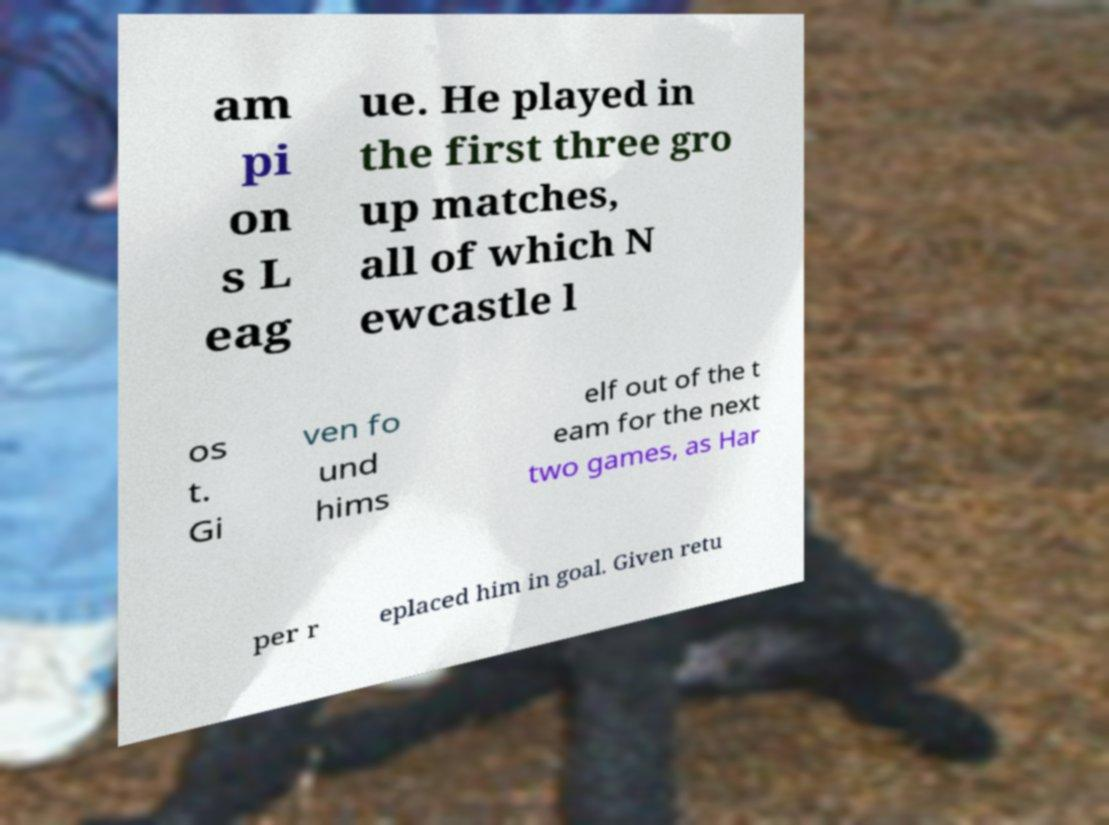I need the written content from this picture converted into text. Can you do that? am pi on s L eag ue. He played in the first three gro up matches, all of which N ewcastle l os t. Gi ven fo und hims elf out of the t eam for the next two games, as Har per r eplaced him in goal. Given retu 